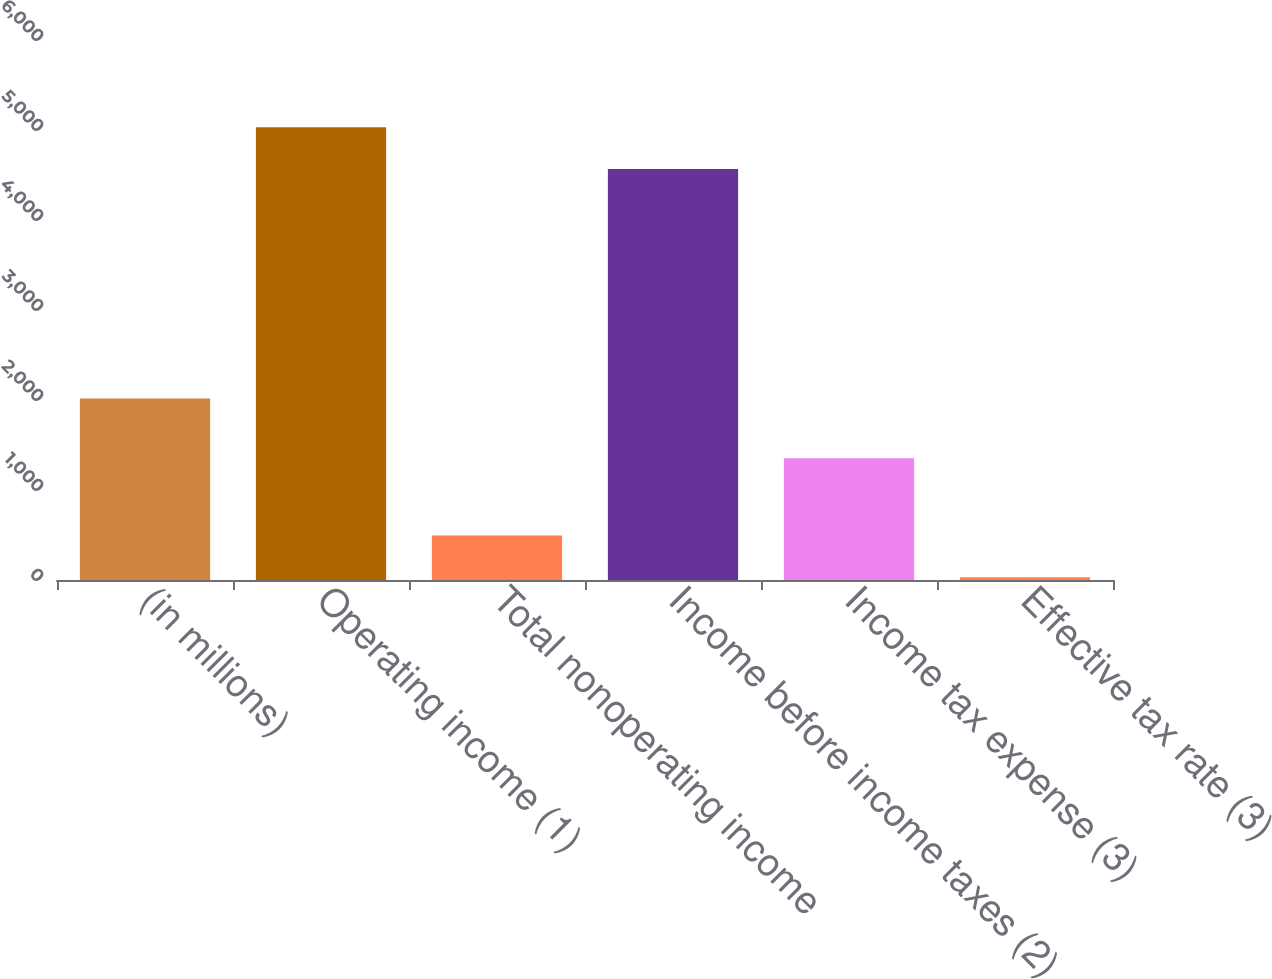<chart> <loc_0><loc_0><loc_500><loc_500><bar_chart><fcel>(in millions)<fcel>Operating income (1)<fcel>Total nonoperating income<fcel>Income before income taxes (2)<fcel>Income tax expense (3)<fcel>Effective tax rate (3)<nl><fcel>2016<fcel>5030.44<fcel>494.04<fcel>4566<fcel>1352<fcel>29.6<nl></chart> 